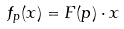<formula> <loc_0><loc_0><loc_500><loc_500>f _ { p } ( x ) = F ( p ) \cdot x</formula> 